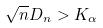<formula> <loc_0><loc_0><loc_500><loc_500>\sqrt { n } D _ { n } > K _ { \alpha }</formula> 